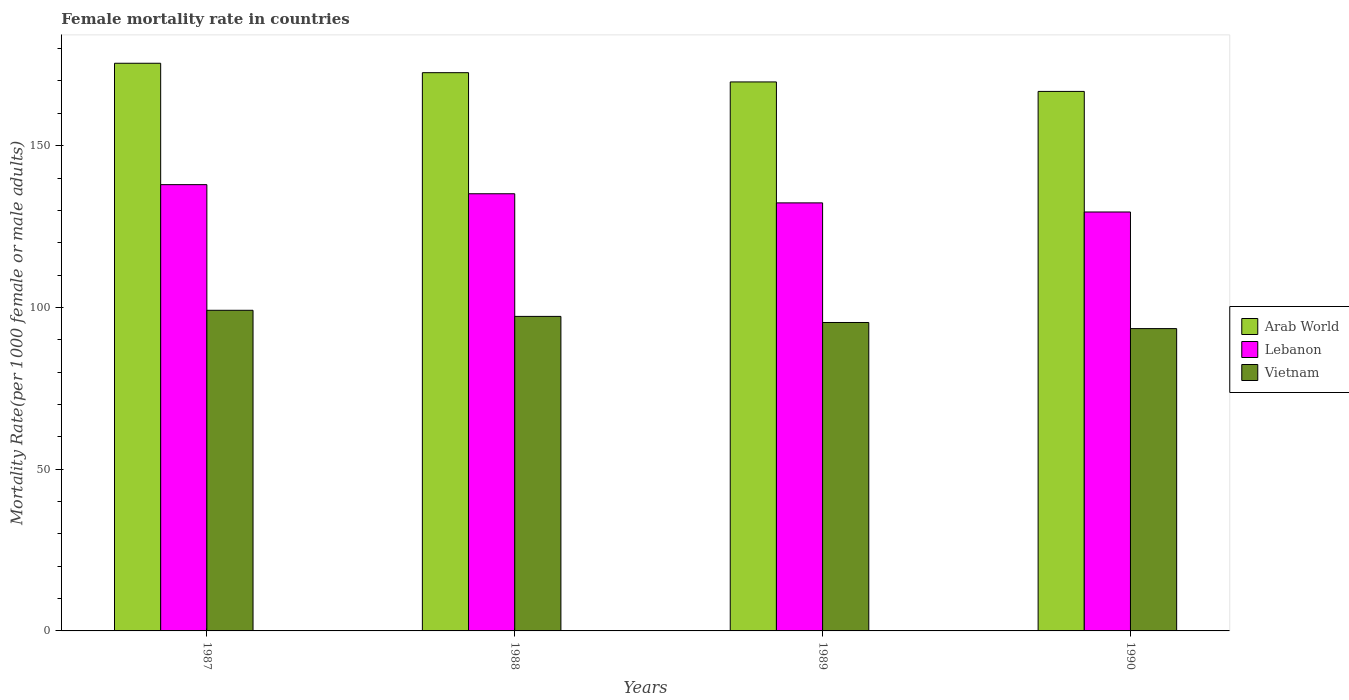How many different coloured bars are there?
Your response must be concise. 3. How many groups of bars are there?
Offer a very short reply. 4. Are the number of bars per tick equal to the number of legend labels?
Your response must be concise. Yes. Are the number of bars on each tick of the X-axis equal?
Your response must be concise. Yes. How many bars are there on the 4th tick from the right?
Your answer should be very brief. 3. What is the female mortality rate in Arab World in 1988?
Offer a terse response. 172.57. Across all years, what is the maximum female mortality rate in Vietnam?
Ensure brevity in your answer.  99.12. Across all years, what is the minimum female mortality rate in Arab World?
Your answer should be very brief. 166.78. In which year was the female mortality rate in Lebanon maximum?
Offer a terse response. 1987. What is the total female mortality rate in Arab World in the graph?
Give a very brief answer. 684.54. What is the difference between the female mortality rate in Vietnam in 1988 and that in 1989?
Make the answer very short. 1.89. What is the difference between the female mortality rate in Arab World in 1987 and the female mortality rate in Vietnam in 1989?
Offer a terse response. 80.14. What is the average female mortality rate in Lebanon per year?
Provide a short and direct response. 133.73. In the year 1987, what is the difference between the female mortality rate in Lebanon and female mortality rate in Vietnam?
Provide a succinct answer. 38.84. In how many years, is the female mortality rate in Lebanon greater than 60?
Offer a terse response. 4. What is the ratio of the female mortality rate in Lebanon in 1987 to that in 1990?
Your answer should be very brief. 1.07. Is the difference between the female mortality rate in Lebanon in 1987 and 1989 greater than the difference between the female mortality rate in Vietnam in 1987 and 1989?
Provide a short and direct response. Yes. What is the difference between the highest and the second highest female mortality rate in Vietnam?
Provide a short and direct response. 1.89. What is the difference between the highest and the lowest female mortality rate in Lebanon?
Provide a short and direct response. 8.45. In how many years, is the female mortality rate in Vietnam greater than the average female mortality rate in Vietnam taken over all years?
Offer a terse response. 2. Is the sum of the female mortality rate in Vietnam in 1987 and 1988 greater than the maximum female mortality rate in Lebanon across all years?
Your answer should be compact. Yes. What does the 2nd bar from the left in 1990 represents?
Offer a terse response. Lebanon. What does the 1st bar from the right in 1990 represents?
Provide a succinct answer. Vietnam. How many bars are there?
Your answer should be very brief. 12. How many years are there in the graph?
Ensure brevity in your answer.  4. Are the values on the major ticks of Y-axis written in scientific E-notation?
Provide a succinct answer. No. Does the graph contain any zero values?
Offer a very short reply. No. Does the graph contain grids?
Make the answer very short. No. How many legend labels are there?
Your answer should be very brief. 3. How are the legend labels stacked?
Offer a very short reply. Vertical. What is the title of the graph?
Provide a succinct answer. Female mortality rate in countries. Does "Greece" appear as one of the legend labels in the graph?
Your answer should be compact. No. What is the label or title of the Y-axis?
Provide a short and direct response. Mortality Rate(per 1000 female or male adults). What is the Mortality Rate(per 1000 female or male adults) in Arab World in 1987?
Make the answer very short. 175.48. What is the Mortality Rate(per 1000 female or male adults) in Lebanon in 1987?
Offer a very short reply. 137.96. What is the Mortality Rate(per 1000 female or male adults) of Vietnam in 1987?
Offer a terse response. 99.12. What is the Mortality Rate(per 1000 female or male adults) in Arab World in 1988?
Ensure brevity in your answer.  172.57. What is the Mortality Rate(per 1000 female or male adults) of Lebanon in 1988?
Give a very brief answer. 135.14. What is the Mortality Rate(per 1000 female or male adults) of Vietnam in 1988?
Make the answer very short. 97.23. What is the Mortality Rate(per 1000 female or male adults) in Arab World in 1989?
Ensure brevity in your answer.  169.71. What is the Mortality Rate(per 1000 female or male adults) of Lebanon in 1989?
Give a very brief answer. 132.32. What is the Mortality Rate(per 1000 female or male adults) in Vietnam in 1989?
Offer a terse response. 95.34. What is the Mortality Rate(per 1000 female or male adults) in Arab World in 1990?
Provide a short and direct response. 166.78. What is the Mortality Rate(per 1000 female or male adults) of Lebanon in 1990?
Provide a succinct answer. 129.51. What is the Mortality Rate(per 1000 female or male adults) of Vietnam in 1990?
Give a very brief answer. 93.46. Across all years, what is the maximum Mortality Rate(per 1000 female or male adults) of Arab World?
Your answer should be very brief. 175.48. Across all years, what is the maximum Mortality Rate(per 1000 female or male adults) in Lebanon?
Offer a terse response. 137.96. Across all years, what is the maximum Mortality Rate(per 1000 female or male adults) of Vietnam?
Provide a short and direct response. 99.12. Across all years, what is the minimum Mortality Rate(per 1000 female or male adults) in Arab World?
Make the answer very short. 166.78. Across all years, what is the minimum Mortality Rate(per 1000 female or male adults) in Lebanon?
Provide a short and direct response. 129.51. Across all years, what is the minimum Mortality Rate(per 1000 female or male adults) of Vietnam?
Your response must be concise. 93.46. What is the total Mortality Rate(per 1000 female or male adults) in Arab World in the graph?
Ensure brevity in your answer.  684.54. What is the total Mortality Rate(per 1000 female or male adults) of Lebanon in the graph?
Your answer should be very brief. 534.93. What is the total Mortality Rate(per 1000 female or male adults) in Vietnam in the graph?
Make the answer very short. 385.15. What is the difference between the Mortality Rate(per 1000 female or male adults) of Arab World in 1987 and that in 1988?
Offer a terse response. 2.91. What is the difference between the Mortality Rate(per 1000 female or male adults) of Lebanon in 1987 and that in 1988?
Offer a very short reply. 2.82. What is the difference between the Mortality Rate(per 1000 female or male adults) in Vietnam in 1987 and that in 1988?
Provide a succinct answer. 1.89. What is the difference between the Mortality Rate(per 1000 female or male adults) in Arab World in 1987 and that in 1989?
Offer a very short reply. 5.77. What is the difference between the Mortality Rate(per 1000 female or male adults) in Lebanon in 1987 and that in 1989?
Give a very brief answer. 5.63. What is the difference between the Mortality Rate(per 1000 female or male adults) of Vietnam in 1987 and that in 1989?
Keep it short and to the point. 3.77. What is the difference between the Mortality Rate(per 1000 female or male adults) in Arab World in 1987 and that in 1990?
Keep it short and to the point. 8.7. What is the difference between the Mortality Rate(per 1000 female or male adults) in Lebanon in 1987 and that in 1990?
Offer a terse response. 8.45. What is the difference between the Mortality Rate(per 1000 female or male adults) of Vietnam in 1987 and that in 1990?
Ensure brevity in your answer.  5.66. What is the difference between the Mortality Rate(per 1000 female or male adults) of Arab World in 1988 and that in 1989?
Provide a short and direct response. 2.86. What is the difference between the Mortality Rate(per 1000 female or male adults) in Lebanon in 1988 and that in 1989?
Ensure brevity in your answer.  2.82. What is the difference between the Mortality Rate(per 1000 female or male adults) of Vietnam in 1988 and that in 1989?
Your answer should be very brief. 1.89. What is the difference between the Mortality Rate(per 1000 female or male adults) of Arab World in 1988 and that in 1990?
Offer a very short reply. 5.79. What is the difference between the Mortality Rate(per 1000 female or male adults) in Lebanon in 1988 and that in 1990?
Give a very brief answer. 5.63. What is the difference between the Mortality Rate(per 1000 female or male adults) in Vietnam in 1988 and that in 1990?
Your answer should be very brief. 3.77. What is the difference between the Mortality Rate(per 1000 female or male adults) in Arab World in 1989 and that in 1990?
Offer a very short reply. 2.93. What is the difference between the Mortality Rate(per 1000 female or male adults) in Lebanon in 1989 and that in 1990?
Ensure brevity in your answer.  2.82. What is the difference between the Mortality Rate(per 1000 female or male adults) in Vietnam in 1989 and that in 1990?
Provide a short and direct response. 1.89. What is the difference between the Mortality Rate(per 1000 female or male adults) of Arab World in 1987 and the Mortality Rate(per 1000 female or male adults) of Lebanon in 1988?
Provide a short and direct response. 40.34. What is the difference between the Mortality Rate(per 1000 female or male adults) in Arab World in 1987 and the Mortality Rate(per 1000 female or male adults) in Vietnam in 1988?
Offer a terse response. 78.25. What is the difference between the Mortality Rate(per 1000 female or male adults) in Lebanon in 1987 and the Mortality Rate(per 1000 female or male adults) in Vietnam in 1988?
Provide a succinct answer. 40.73. What is the difference between the Mortality Rate(per 1000 female or male adults) in Arab World in 1987 and the Mortality Rate(per 1000 female or male adults) in Lebanon in 1989?
Your answer should be compact. 43.16. What is the difference between the Mortality Rate(per 1000 female or male adults) of Arab World in 1987 and the Mortality Rate(per 1000 female or male adults) of Vietnam in 1989?
Give a very brief answer. 80.14. What is the difference between the Mortality Rate(per 1000 female or male adults) of Lebanon in 1987 and the Mortality Rate(per 1000 female or male adults) of Vietnam in 1989?
Offer a terse response. 42.61. What is the difference between the Mortality Rate(per 1000 female or male adults) in Arab World in 1987 and the Mortality Rate(per 1000 female or male adults) in Lebanon in 1990?
Your response must be concise. 45.98. What is the difference between the Mortality Rate(per 1000 female or male adults) of Arab World in 1987 and the Mortality Rate(per 1000 female or male adults) of Vietnam in 1990?
Your response must be concise. 82.03. What is the difference between the Mortality Rate(per 1000 female or male adults) in Lebanon in 1987 and the Mortality Rate(per 1000 female or male adults) in Vietnam in 1990?
Your answer should be compact. 44.5. What is the difference between the Mortality Rate(per 1000 female or male adults) in Arab World in 1988 and the Mortality Rate(per 1000 female or male adults) in Lebanon in 1989?
Ensure brevity in your answer.  40.25. What is the difference between the Mortality Rate(per 1000 female or male adults) of Arab World in 1988 and the Mortality Rate(per 1000 female or male adults) of Vietnam in 1989?
Offer a very short reply. 77.22. What is the difference between the Mortality Rate(per 1000 female or male adults) in Lebanon in 1988 and the Mortality Rate(per 1000 female or male adults) in Vietnam in 1989?
Offer a terse response. 39.8. What is the difference between the Mortality Rate(per 1000 female or male adults) of Arab World in 1988 and the Mortality Rate(per 1000 female or male adults) of Lebanon in 1990?
Ensure brevity in your answer.  43.06. What is the difference between the Mortality Rate(per 1000 female or male adults) in Arab World in 1988 and the Mortality Rate(per 1000 female or male adults) in Vietnam in 1990?
Provide a succinct answer. 79.11. What is the difference between the Mortality Rate(per 1000 female or male adults) of Lebanon in 1988 and the Mortality Rate(per 1000 female or male adults) of Vietnam in 1990?
Your answer should be very brief. 41.68. What is the difference between the Mortality Rate(per 1000 female or male adults) in Arab World in 1989 and the Mortality Rate(per 1000 female or male adults) in Lebanon in 1990?
Provide a short and direct response. 40.2. What is the difference between the Mortality Rate(per 1000 female or male adults) of Arab World in 1989 and the Mortality Rate(per 1000 female or male adults) of Vietnam in 1990?
Offer a very short reply. 76.25. What is the difference between the Mortality Rate(per 1000 female or male adults) in Lebanon in 1989 and the Mortality Rate(per 1000 female or male adults) in Vietnam in 1990?
Keep it short and to the point. 38.87. What is the average Mortality Rate(per 1000 female or male adults) in Arab World per year?
Give a very brief answer. 171.14. What is the average Mortality Rate(per 1000 female or male adults) of Lebanon per year?
Your answer should be very brief. 133.73. What is the average Mortality Rate(per 1000 female or male adults) of Vietnam per year?
Your response must be concise. 96.29. In the year 1987, what is the difference between the Mortality Rate(per 1000 female or male adults) in Arab World and Mortality Rate(per 1000 female or male adults) in Lebanon?
Your answer should be compact. 37.53. In the year 1987, what is the difference between the Mortality Rate(per 1000 female or male adults) in Arab World and Mortality Rate(per 1000 female or male adults) in Vietnam?
Keep it short and to the point. 76.37. In the year 1987, what is the difference between the Mortality Rate(per 1000 female or male adults) of Lebanon and Mortality Rate(per 1000 female or male adults) of Vietnam?
Your response must be concise. 38.84. In the year 1988, what is the difference between the Mortality Rate(per 1000 female or male adults) of Arab World and Mortality Rate(per 1000 female or male adults) of Lebanon?
Ensure brevity in your answer.  37.43. In the year 1988, what is the difference between the Mortality Rate(per 1000 female or male adults) in Arab World and Mortality Rate(per 1000 female or male adults) in Vietnam?
Provide a succinct answer. 75.34. In the year 1988, what is the difference between the Mortality Rate(per 1000 female or male adults) in Lebanon and Mortality Rate(per 1000 female or male adults) in Vietnam?
Your answer should be very brief. 37.91. In the year 1989, what is the difference between the Mortality Rate(per 1000 female or male adults) of Arab World and Mortality Rate(per 1000 female or male adults) of Lebanon?
Provide a short and direct response. 37.39. In the year 1989, what is the difference between the Mortality Rate(per 1000 female or male adults) in Arab World and Mortality Rate(per 1000 female or male adults) in Vietnam?
Ensure brevity in your answer.  74.37. In the year 1989, what is the difference between the Mortality Rate(per 1000 female or male adults) of Lebanon and Mortality Rate(per 1000 female or male adults) of Vietnam?
Your answer should be compact. 36.98. In the year 1990, what is the difference between the Mortality Rate(per 1000 female or male adults) in Arab World and Mortality Rate(per 1000 female or male adults) in Lebanon?
Ensure brevity in your answer.  37.27. In the year 1990, what is the difference between the Mortality Rate(per 1000 female or male adults) in Arab World and Mortality Rate(per 1000 female or male adults) in Vietnam?
Your answer should be compact. 73.32. In the year 1990, what is the difference between the Mortality Rate(per 1000 female or male adults) in Lebanon and Mortality Rate(per 1000 female or male adults) in Vietnam?
Your answer should be very brief. 36.05. What is the ratio of the Mortality Rate(per 1000 female or male adults) in Arab World in 1987 to that in 1988?
Give a very brief answer. 1.02. What is the ratio of the Mortality Rate(per 1000 female or male adults) of Lebanon in 1987 to that in 1988?
Ensure brevity in your answer.  1.02. What is the ratio of the Mortality Rate(per 1000 female or male adults) of Vietnam in 1987 to that in 1988?
Provide a short and direct response. 1.02. What is the ratio of the Mortality Rate(per 1000 female or male adults) of Arab World in 1987 to that in 1989?
Provide a succinct answer. 1.03. What is the ratio of the Mortality Rate(per 1000 female or male adults) of Lebanon in 1987 to that in 1989?
Your answer should be very brief. 1.04. What is the ratio of the Mortality Rate(per 1000 female or male adults) of Vietnam in 1987 to that in 1989?
Keep it short and to the point. 1.04. What is the ratio of the Mortality Rate(per 1000 female or male adults) of Arab World in 1987 to that in 1990?
Offer a terse response. 1.05. What is the ratio of the Mortality Rate(per 1000 female or male adults) of Lebanon in 1987 to that in 1990?
Make the answer very short. 1.07. What is the ratio of the Mortality Rate(per 1000 female or male adults) in Vietnam in 1987 to that in 1990?
Ensure brevity in your answer.  1.06. What is the ratio of the Mortality Rate(per 1000 female or male adults) of Arab World in 1988 to that in 1989?
Make the answer very short. 1.02. What is the ratio of the Mortality Rate(per 1000 female or male adults) of Lebanon in 1988 to that in 1989?
Your answer should be compact. 1.02. What is the ratio of the Mortality Rate(per 1000 female or male adults) of Vietnam in 1988 to that in 1989?
Make the answer very short. 1.02. What is the ratio of the Mortality Rate(per 1000 female or male adults) of Arab World in 1988 to that in 1990?
Ensure brevity in your answer.  1.03. What is the ratio of the Mortality Rate(per 1000 female or male adults) of Lebanon in 1988 to that in 1990?
Offer a terse response. 1.04. What is the ratio of the Mortality Rate(per 1000 female or male adults) in Vietnam in 1988 to that in 1990?
Your response must be concise. 1.04. What is the ratio of the Mortality Rate(per 1000 female or male adults) of Arab World in 1989 to that in 1990?
Your response must be concise. 1.02. What is the ratio of the Mortality Rate(per 1000 female or male adults) of Lebanon in 1989 to that in 1990?
Your answer should be compact. 1.02. What is the ratio of the Mortality Rate(per 1000 female or male adults) in Vietnam in 1989 to that in 1990?
Make the answer very short. 1.02. What is the difference between the highest and the second highest Mortality Rate(per 1000 female or male adults) in Arab World?
Provide a short and direct response. 2.91. What is the difference between the highest and the second highest Mortality Rate(per 1000 female or male adults) in Lebanon?
Provide a short and direct response. 2.82. What is the difference between the highest and the second highest Mortality Rate(per 1000 female or male adults) of Vietnam?
Offer a terse response. 1.89. What is the difference between the highest and the lowest Mortality Rate(per 1000 female or male adults) in Arab World?
Ensure brevity in your answer.  8.7. What is the difference between the highest and the lowest Mortality Rate(per 1000 female or male adults) in Lebanon?
Provide a succinct answer. 8.45. What is the difference between the highest and the lowest Mortality Rate(per 1000 female or male adults) in Vietnam?
Ensure brevity in your answer.  5.66. 